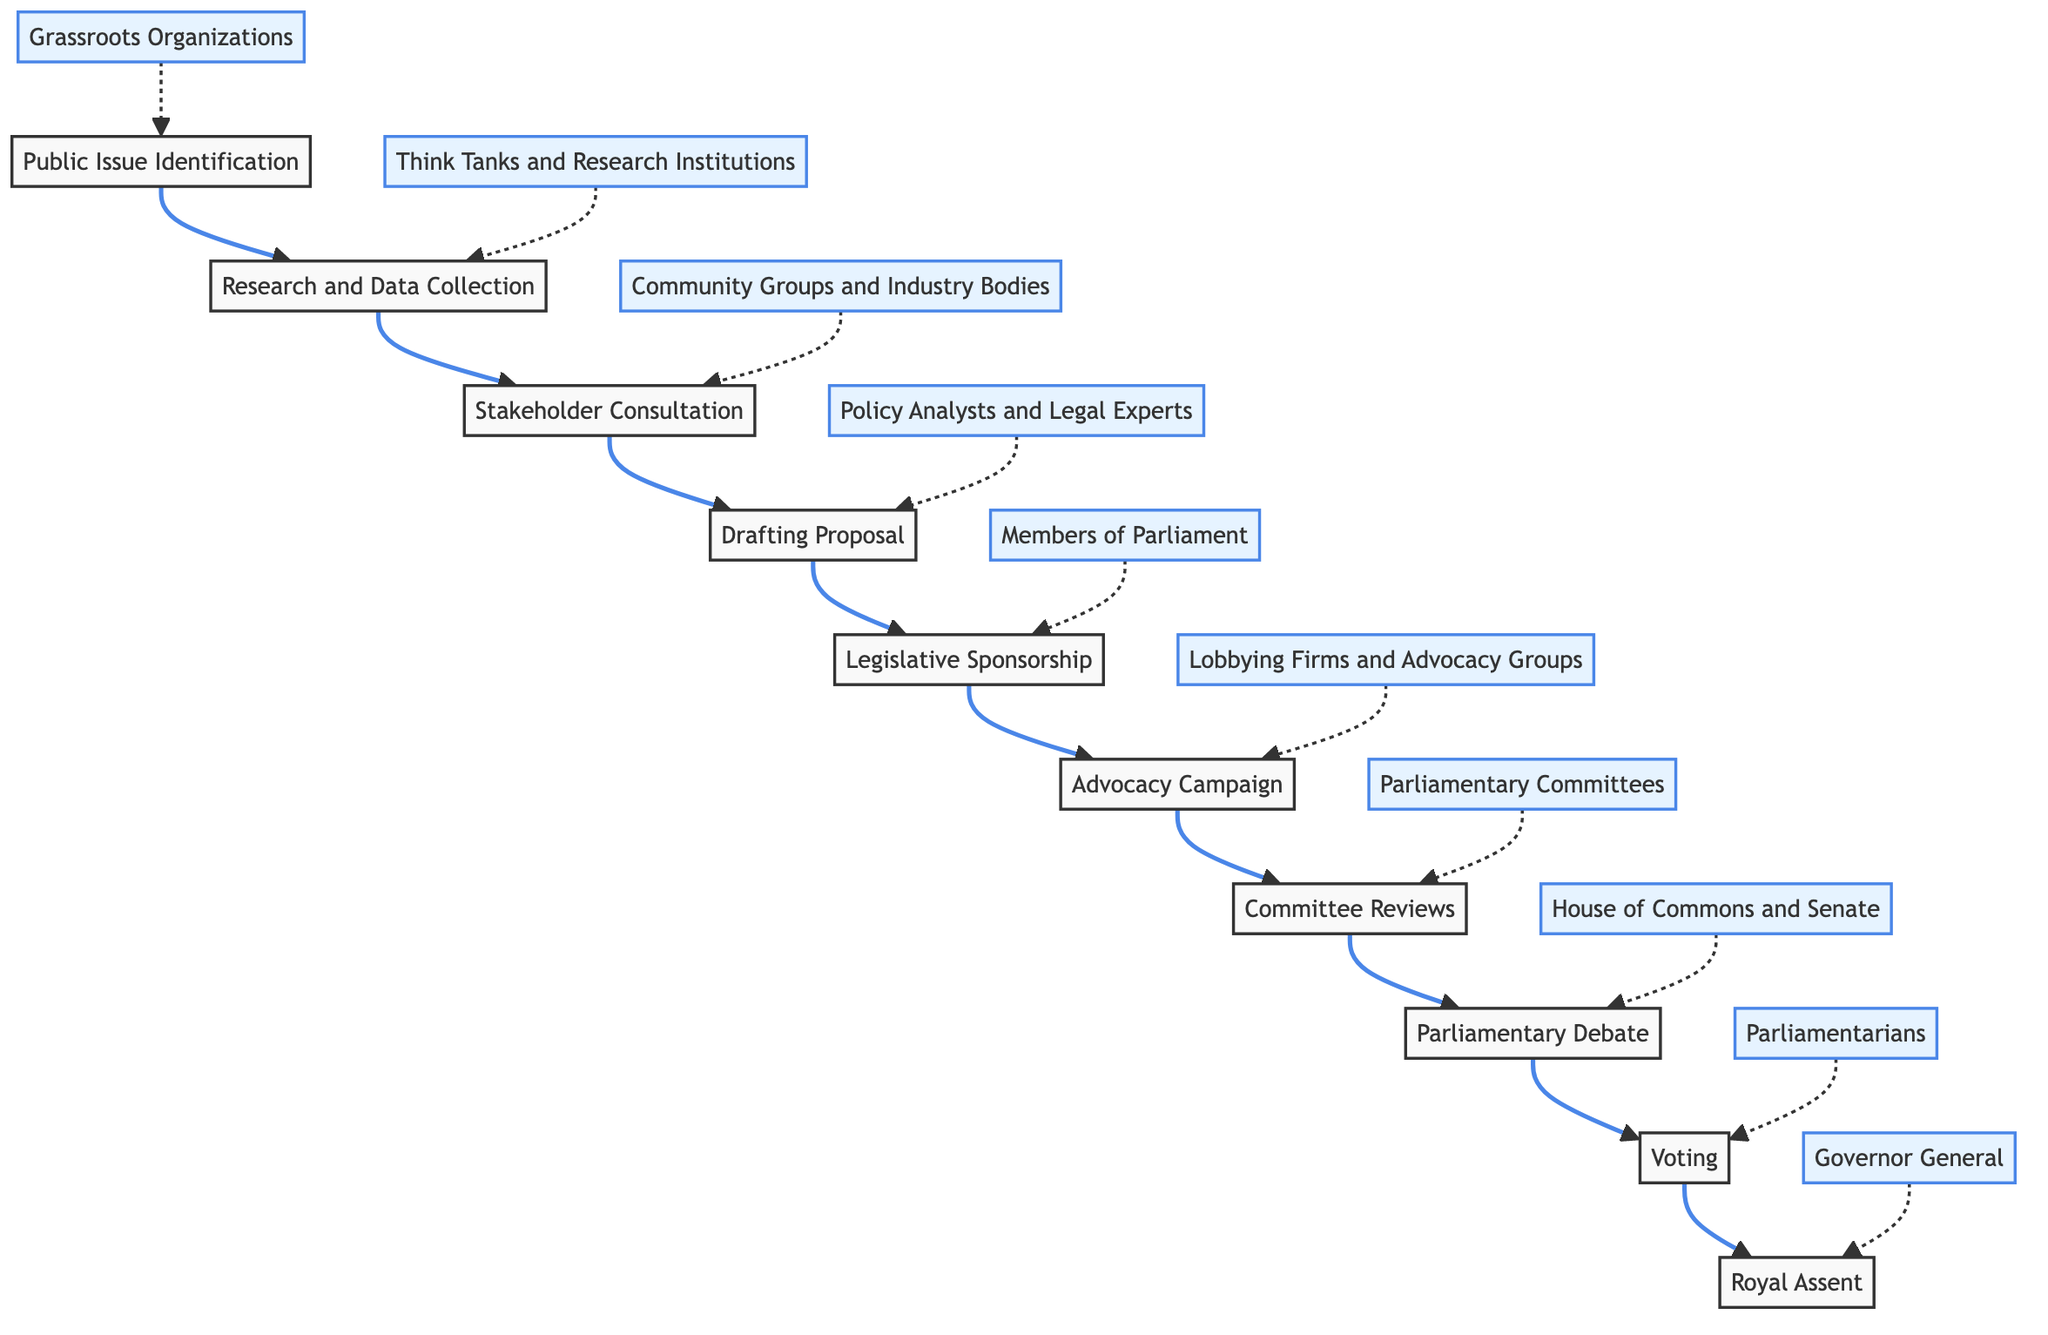What is the first step in the amending process? The first step, as shown in the diagram, is "Public Issue Identification", where the public issue or societal need that requires legislative change is identified.
Answer: Public Issue Identification How many total steps are there in the flow chart? By counting each distinct process represented in the flow chart, we find there are ten steps from identification to royal assent.
Answer: 10 Which entities are involved in drafting the proposal? The diagram indicates that "Policy Analysts and Legal Experts" are responsible for the "Drafting Proposal" step of the process.
Answer: Policy Analysts and Legal Experts What follows after the Advocacy Campaign step? Referring to the flow chart, after the "Advocacy Campaign", the next step is "Committee Reviews", where the draft is reviewed and refined.
Answer: Committee Reviews Who provides the final approval of the amendment? According to the flow chart, the final approval is granted by the "Governor General", who represents the ceremonial head of state.
Answer: Governor General What stage involves engaging with various stakeholders? The "Stakeholder Consultation" stage involves engaging with various stakeholders to gather different perspectives and build support for the proposal.
Answer: Stakeholder Consultation Which step involves parliamentary members voting? The step where parliamentary members vote on the proposed amendment is marked as "Voting" in the flow chart.
Answer: Voting What is the purpose of the Committee Reviews stage? The "Committee Reviews" stage is intended for the review and refinement of the draft by legislative committees.
Answer: Review and refinement What kind of groups launch the Advocacy Campaign? The diagram specifies that "Lobbying Firms and Advocacy Groups" are the entities that launch the Advocacy Campaign to build support for the amendment.
Answer: Lobbying Firms and Advocacy Groups What is the relationship between "Drafting Proposal" and "Legislative Sponsorship"? "Drafting Proposal" leads directly to "Legislative Sponsorship" as a step in the process where the drafted proposal seeks a legislative sponsor for introduction.
Answer: Drafting Proposal leads to Legislative Sponsorship 